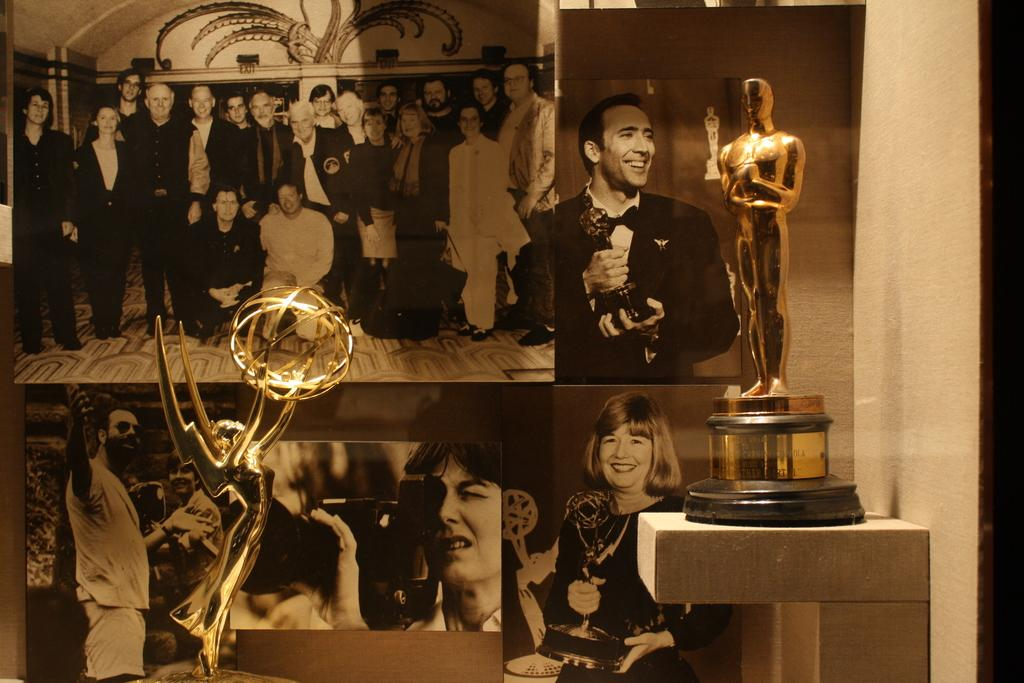What can be seen in the foreground of the image? There are two trophies in the foreground of the image. How are the trophies positioned in the image? The trophies are placed on stands. What is visible in the background of the image? In the background of the image, there is a group of photos pasted on the wall. How many boys are holding forks in the image? There are no boys or forks present in the image. 